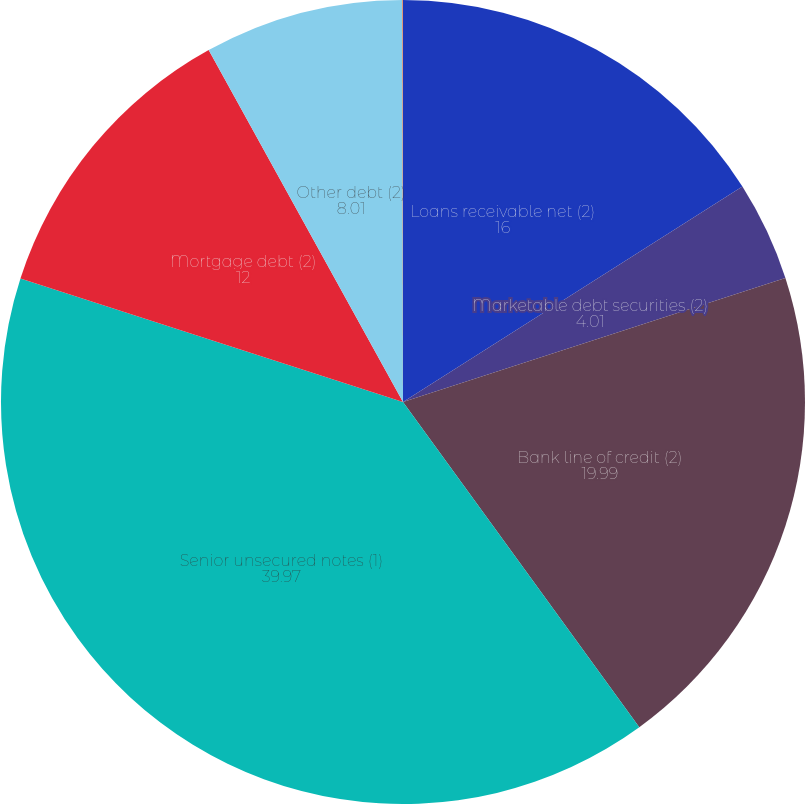Convert chart to OTSL. <chart><loc_0><loc_0><loc_500><loc_500><pie_chart><fcel>Loans receivable net (2)<fcel>Marketable debt securities (2)<fcel>Bank line of credit (2)<fcel>Senior unsecured notes (1)<fcel>Mortgage debt (2)<fcel>Other debt (2)<fcel>Interest-rate swap liabilities<nl><fcel>16.0%<fcel>4.01%<fcel>19.99%<fcel>39.97%<fcel>12.0%<fcel>8.01%<fcel>0.02%<nl></chart> 